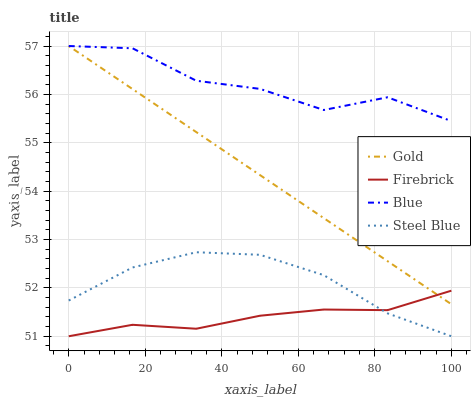Does Steel Blue have the minimum area under the curve?
Answer yes or no. No. Does Steel Blue have the maximum area under the curve?
Answer yes or no. No. Is Firebrick the smoothest?
Answer yes or no. No. Is Firebrick the roughest?
Answer yes or no. No. Does Gold have the lowest value?
Answer yes or no. No. Does Steel Blue have the highest value?
Answer yes or no. No. Is Steel Blue less than Blue?
Answer yes or no. Yes. Is Gold greater than Steel Blue?
Answer yes or no. Yes. Does Steel Blue intersect Blue?
Answer yes or no. No. 